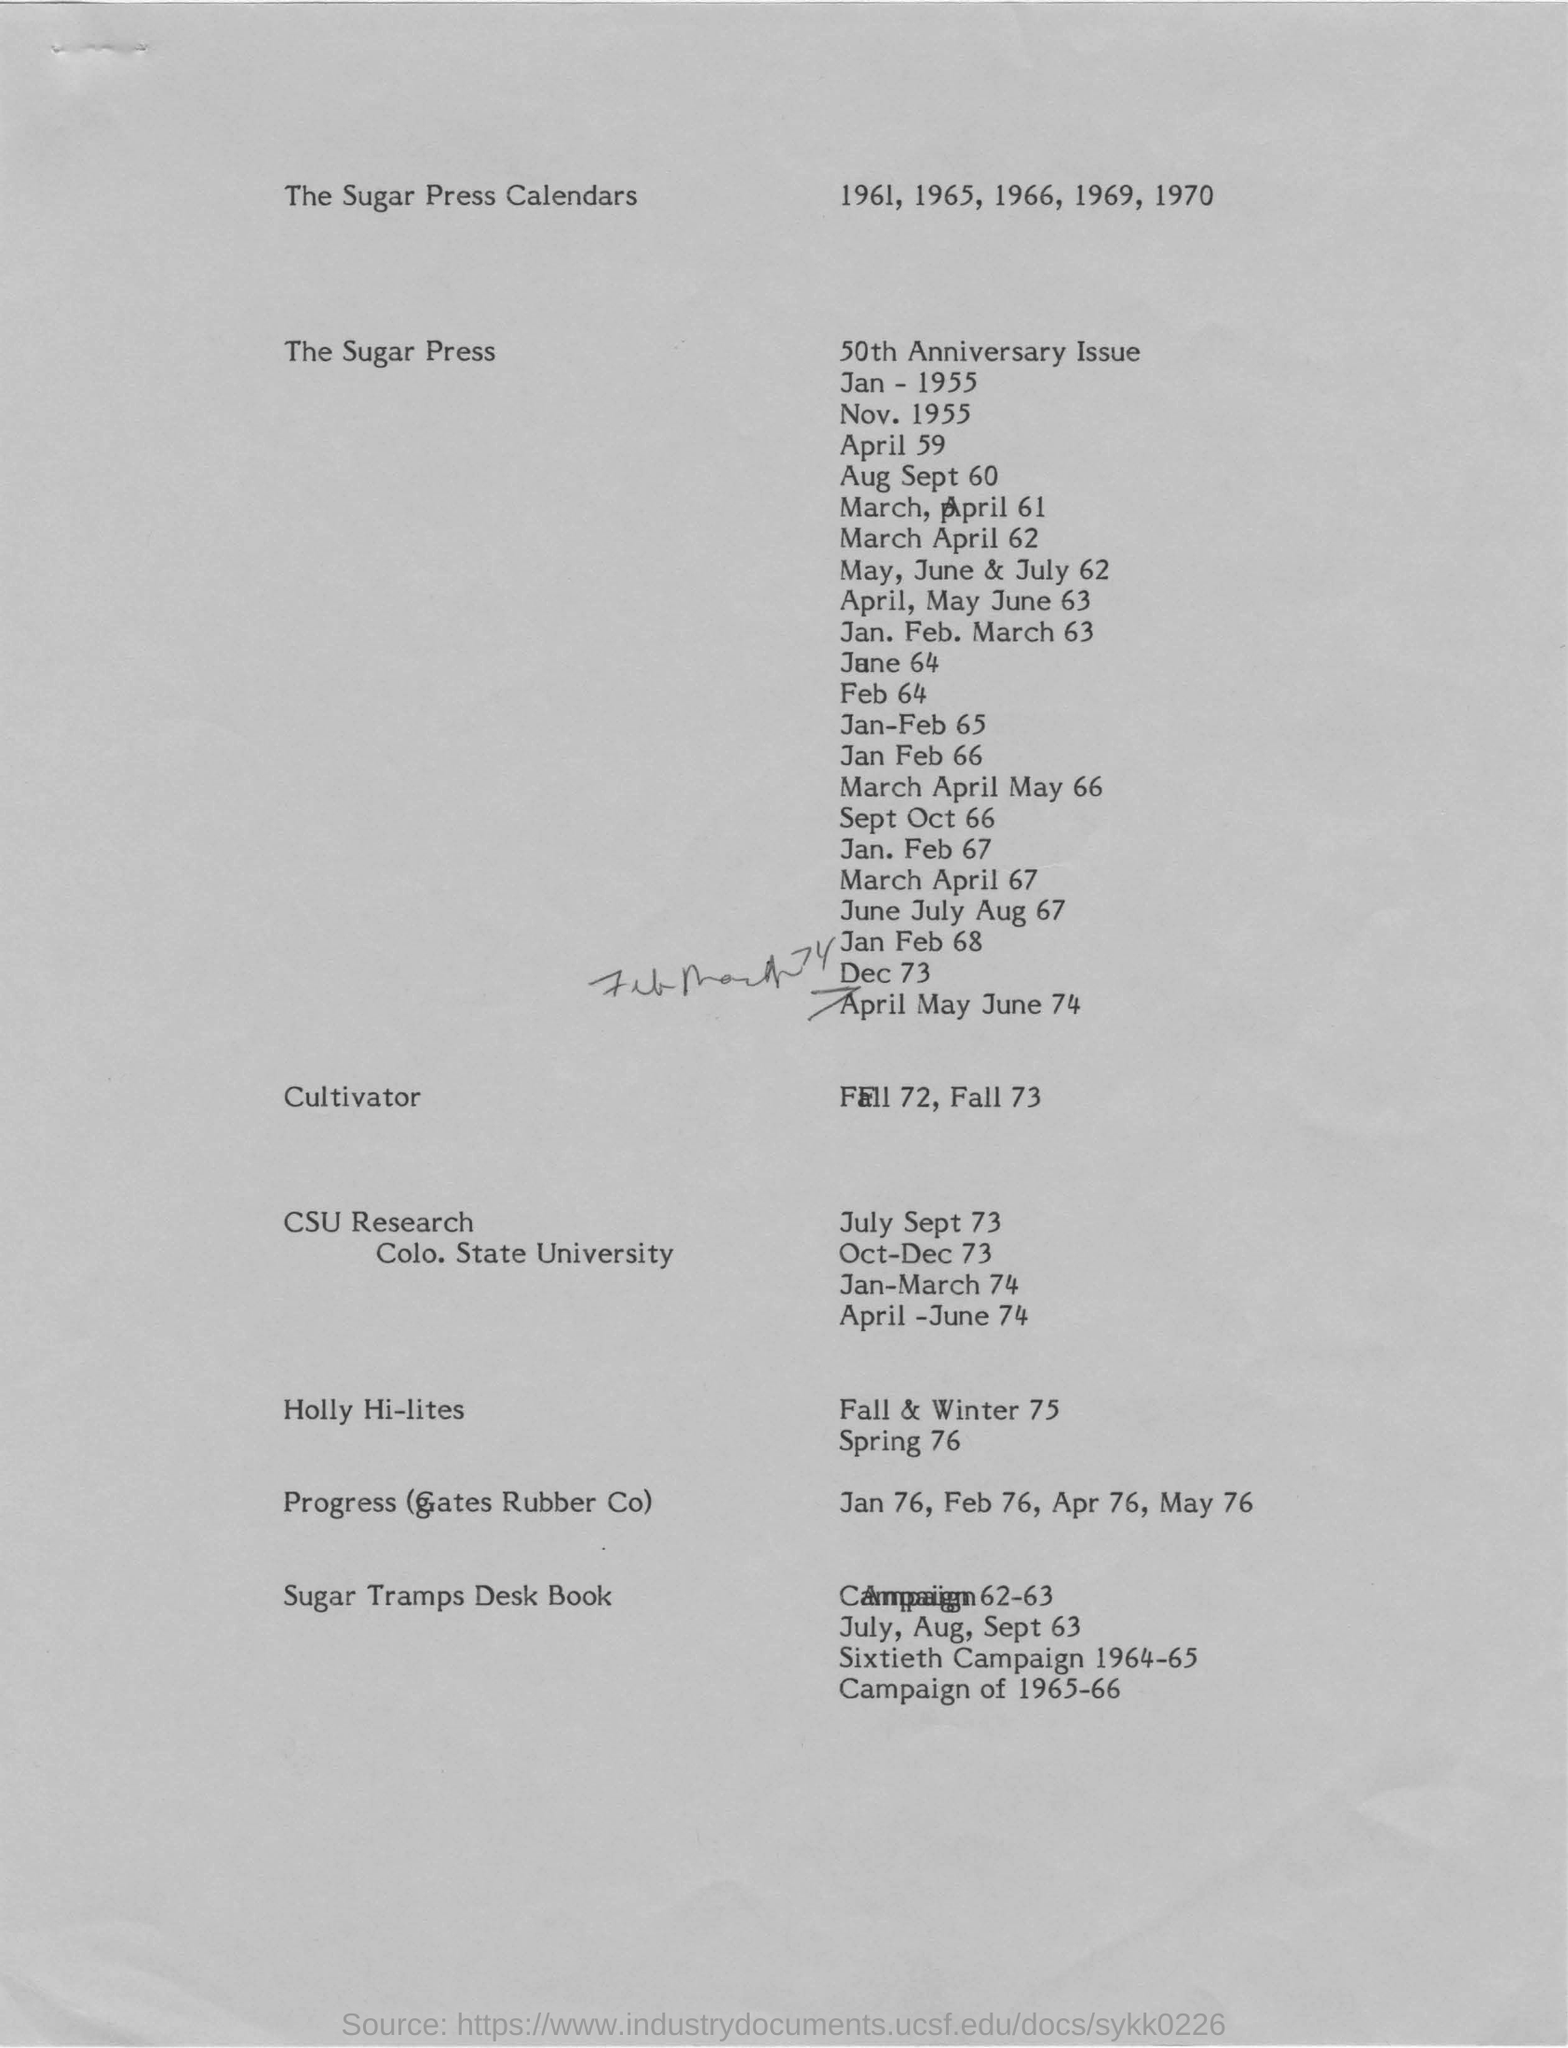Which years are mentioned in the sugar press calendars?
Provide a succinct answer. 1961, 1965, 1966, 1969, 1970. What is mentioned related to fall 72 and fall 73?
Provide a short and direct response. Cultivator. What does CSU stands for?
Your answer should be compact. COLO. STATE UNIVERSITY. 